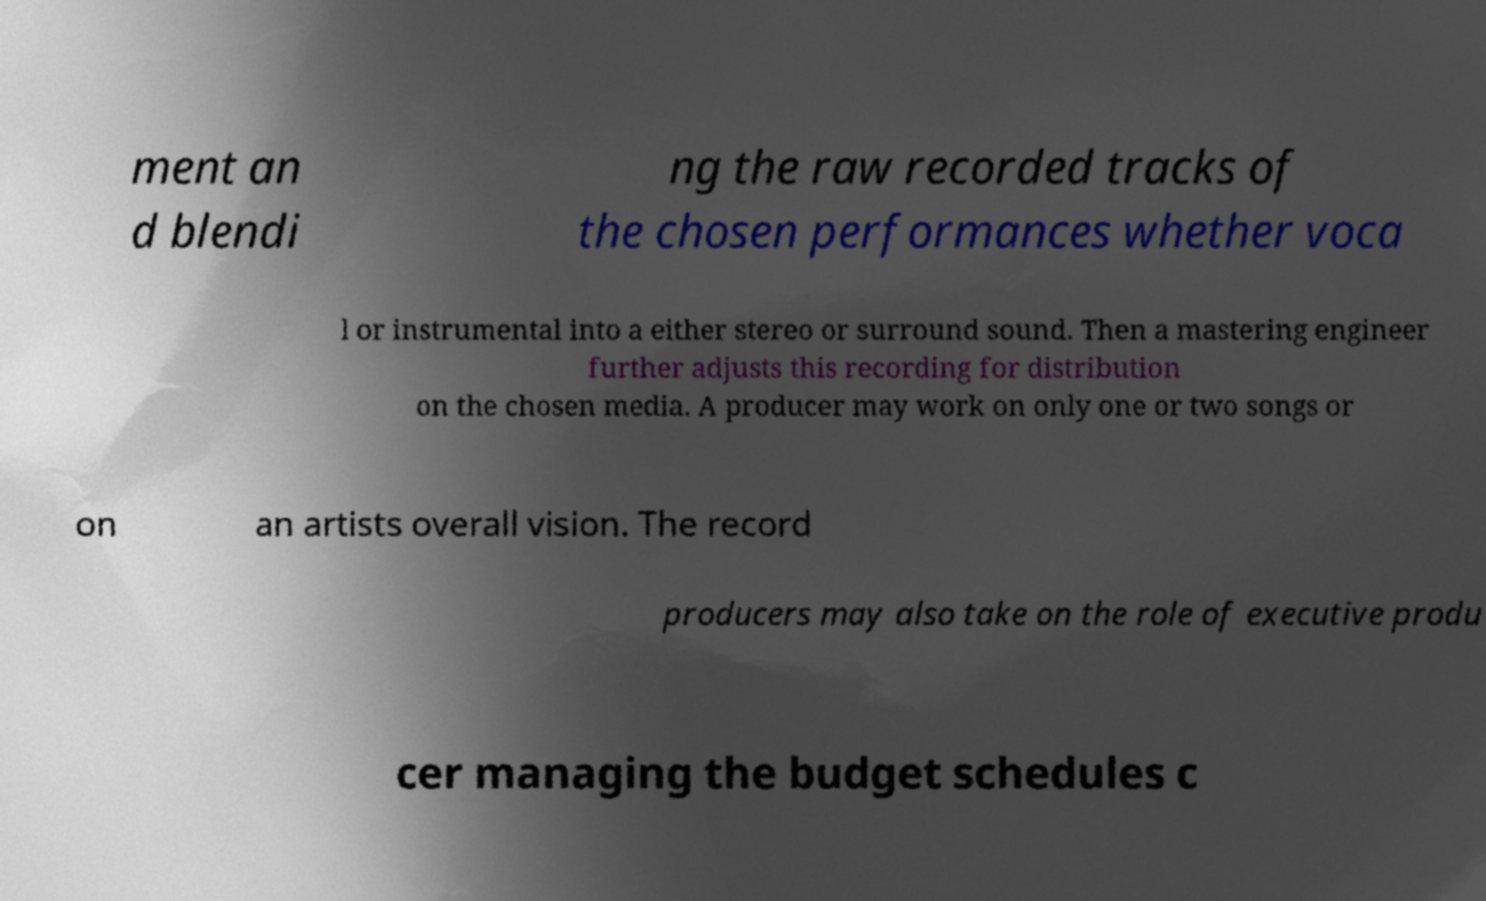I need the written content from this picture converted into text. Can you do that? ment an d blendi ng the raw recorded tracks of the chosen performances whether voca l or instrumental into a either stereo or surround sound. Then a mastering engineer further adjusts this recording for distribution on the chosen media. A producer may work on only one or two songs or on an artists overall vision. The record producers may also take on the role of executive produ cer managing the budget schedules c 